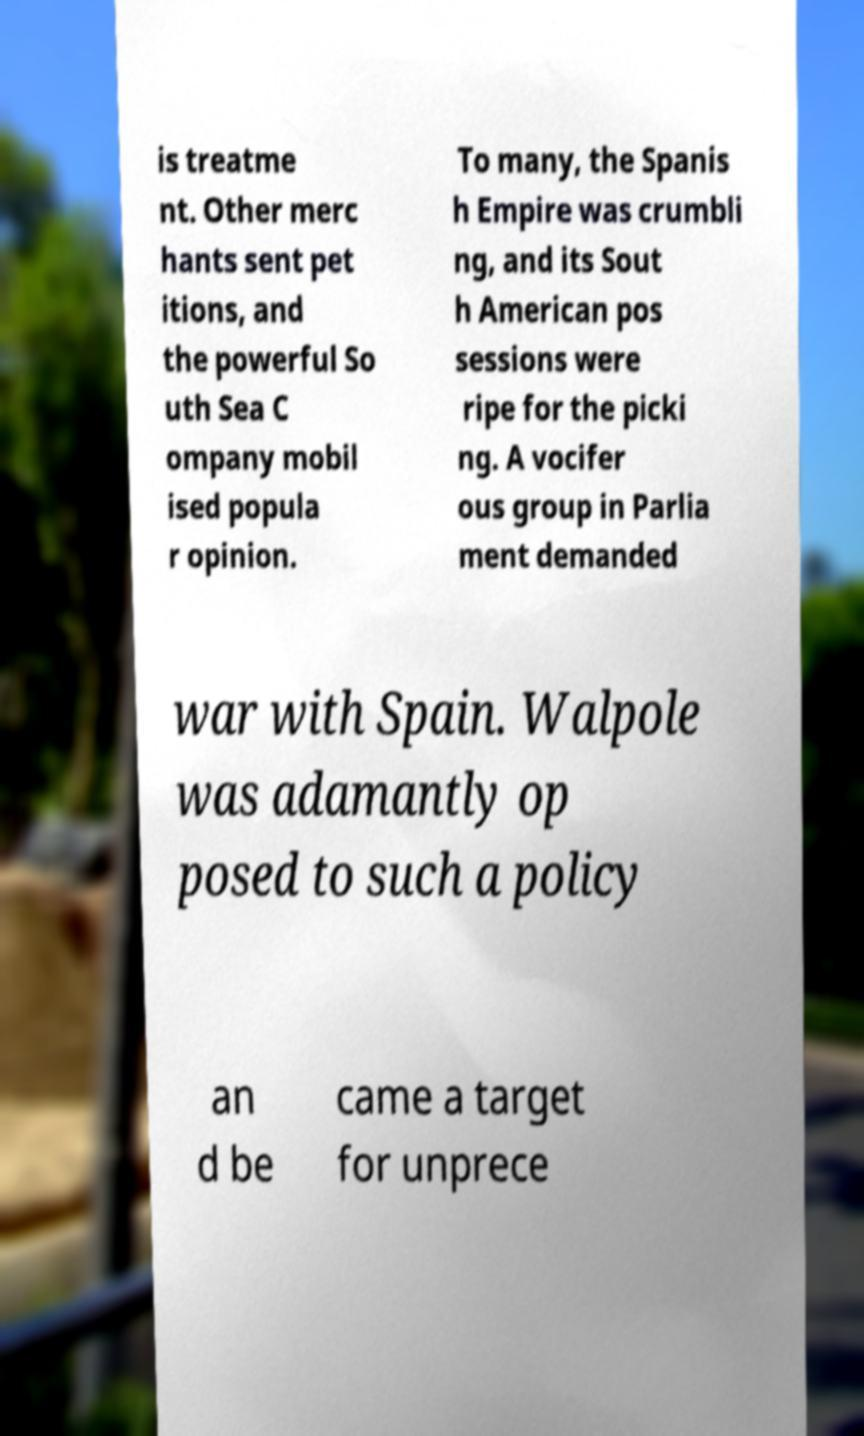Can you accurately transcribe the text from the provided image for me? is treatme nt. Other merc hants sent pet itions, and the powerful So uth Sea C ompany mobil ised popula r opinion. To many, the Spanis h Empire was crumbli ng, and its Sout h American pos sessions were ripe for the picki ng. A vocifer ous group in Parlia ment demanded war with Spain. Walpole was adamantly op posed to such a policy an d be came a target for unprece 